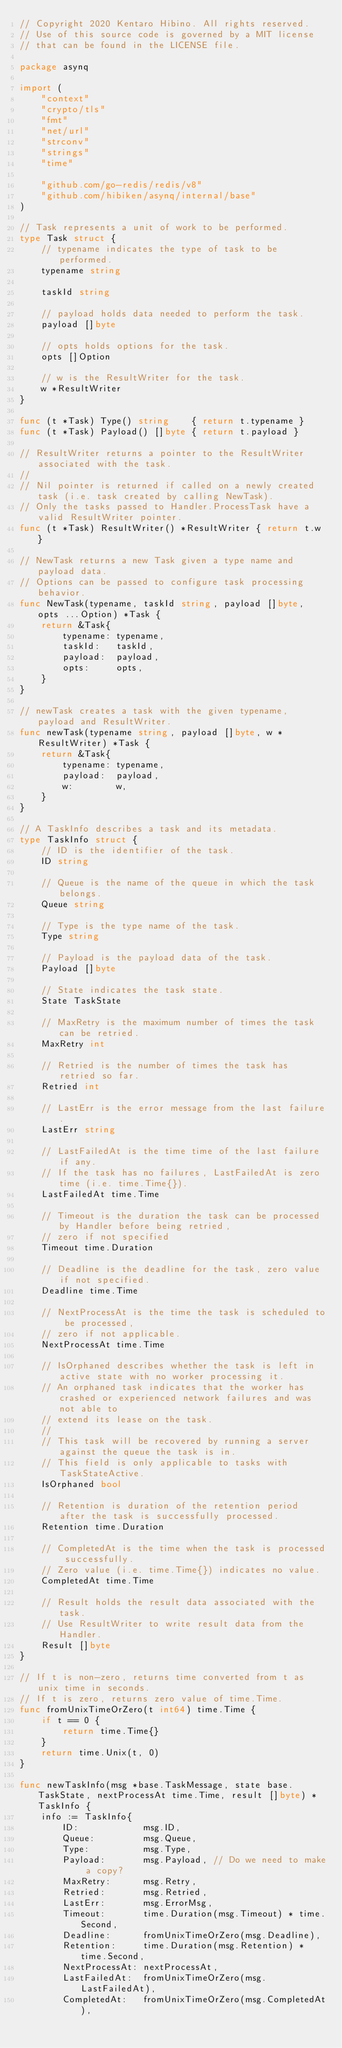Convert code to text. <code><loc_0><loc_0><loc_500><loc_500><_Go_>// Copyright 2020 Kentaro Hibino. All rights reserved.
// Use of this source code is governed by a MIT license
// that can be found in the LICENSE file.

package asynq

import (
	"context"
	"crypto/tls"
	"fmt"
	"net/url"
	"strconv"
	"strings"
	"time"

	"github.com/go-redis/redis/v8"
	"github.com/hibiken/asynq/internal/base"
)

// Task represents a unit of work to be performed.
type Task struct {
	// typename indicates the type of task to be performed.
	typename string

	taskId string

	// payload holds data needed to perform the task.
	payload []byte

	// opts holds options for the task.
	opts []Option

	// w is the ResultWriter for the task.
	w *ResultWriter
}

func (t *Task) Type() string    { return t.typename }
func (t *Task) Payload() []byte { return t.payload }

// ResultWriter returns a pointer to the ResultWriter associated with the task.
//
// Nil pointer is returned if called on a newly created task (i.e. task created by calling NewTask).
// Only the tasks passed to Handler.ProcessTask have a valid ResultWriter pointer.
func (t *Task) ResultWriter() *ResultWriter { return t.w }

// NewTask returns a new Task given a type name and payload data.
// Options can be passed to configure task processing behavior.
func NewTask(typename, taskId string, payload []byte, opts ...Option) *Task {
	return &Task{
		typename: typename,
		taskId:   taskId,
		payload:  payload,
		opts:     opts,
	}
}

// newTask creates a task with the given typename, payload and ResultWriter.
func newTask(typename string, payload []byte, w *ResultWriter) *Task {
	return &Task{
		typename: typename,
		payload:  payload,
		w:        w,
	}
}

// A TaskInfo describes a task and its metadata.
type TaskInfo struct {
	// ID is the identifier of the task.
	ID string

	// Queue is the name of the queue in which the task belongs.
	Queue string

	// Type is the type name of the task.
	Type string

	// Payload is the payload data of the task.
	Payload []byte

	// State indicates the task state.
	State TaskState

	// MaxRetry is the maximum number of times the task can be retried.
	MaxRetry int

	// Retried is the number of times the task has retried so far.
	Retried int

	// LastErr is the error message from the last failure.
	LastErr string

	// LastFailedAt is the time time of the last failure if any.
	// If the task has no failures, LastFailedAt is zero time (i.e. time.Time{}).
	LastFailedAt time.Time

	// Timeout is the duration the task can be processed by Handler before being retried,
	// zero if not specified
	Timeout time.Duration

	// Deadline is the deadline for the task, zero value if not specified.
	Deadline time.Time

	// NextProcessAt is the time the task is scheduled to be processed,
	// zero if not applicable.
	NextProcessAt time.Time

	// IsOrphaned describes whether the task is left in active state with no worker processing it.
	// An orphaned task indicates that the worker has crashed or experienced network failures and was not able to
	// extend its lease on the task.
	//
	// This task will be recovered by running a server against the queue the task is in.
	// This field is only applicable to tasks with TaskStateActive.
	IsOrphaned bool

	// Retention is duration of the retention period after the task is successfully processed.
	Retention time.Duration

	// CompletedAt is the time when the task is processed successfully.
	// Zero value (i.e. time.Time{}) indicates no value.
	CompletedAt time.Time

	// Result holds the result data associated with the task.
	// Use ResultWriter to write result data from the Handler.
	Result []byte
}

// If t is non-zero, returns time converted from t as unix time in seconds.
// If t is zero, returns zero value of time.Time.
func fromUnixTimeOrZero(t int64) time.Time {
	if t == 0 {
		return time.Time{}
	}
	return time.Unix(t, 0)
}

func newTaskInfo(msg *base.TaskMessage, state base.TaskState, nextProcessAt time.Time, result []byte) *TaskInfo {
	info := TaskInfo{
		ID:            msg.ID,
		Queue:         msg.Queue,
		Type:          msg.Type,
		Payload:       msg.Payload, // Do we need to make a copy?
		MaxRetry:      msg.Retry,
		Retried:       msg.Retried,
		LastErr:       msg.ErrorMsg,
		Timeout:       time.Duration(msg.Timeout) * time.Second,
		Deadline:      fromUnixTimeOrZero(msg.Deadline),
		Retention:     time.Duration(msg.Retention) * time.Second,
		NextProcessAt: nextProcessAt,
		LastFailedAt:  fromUnixTimeOrZero(msg.LastFailedAt),
		CompletedAt:   fromUnixTimeOrZero(msg.CompletedAt),</code> 